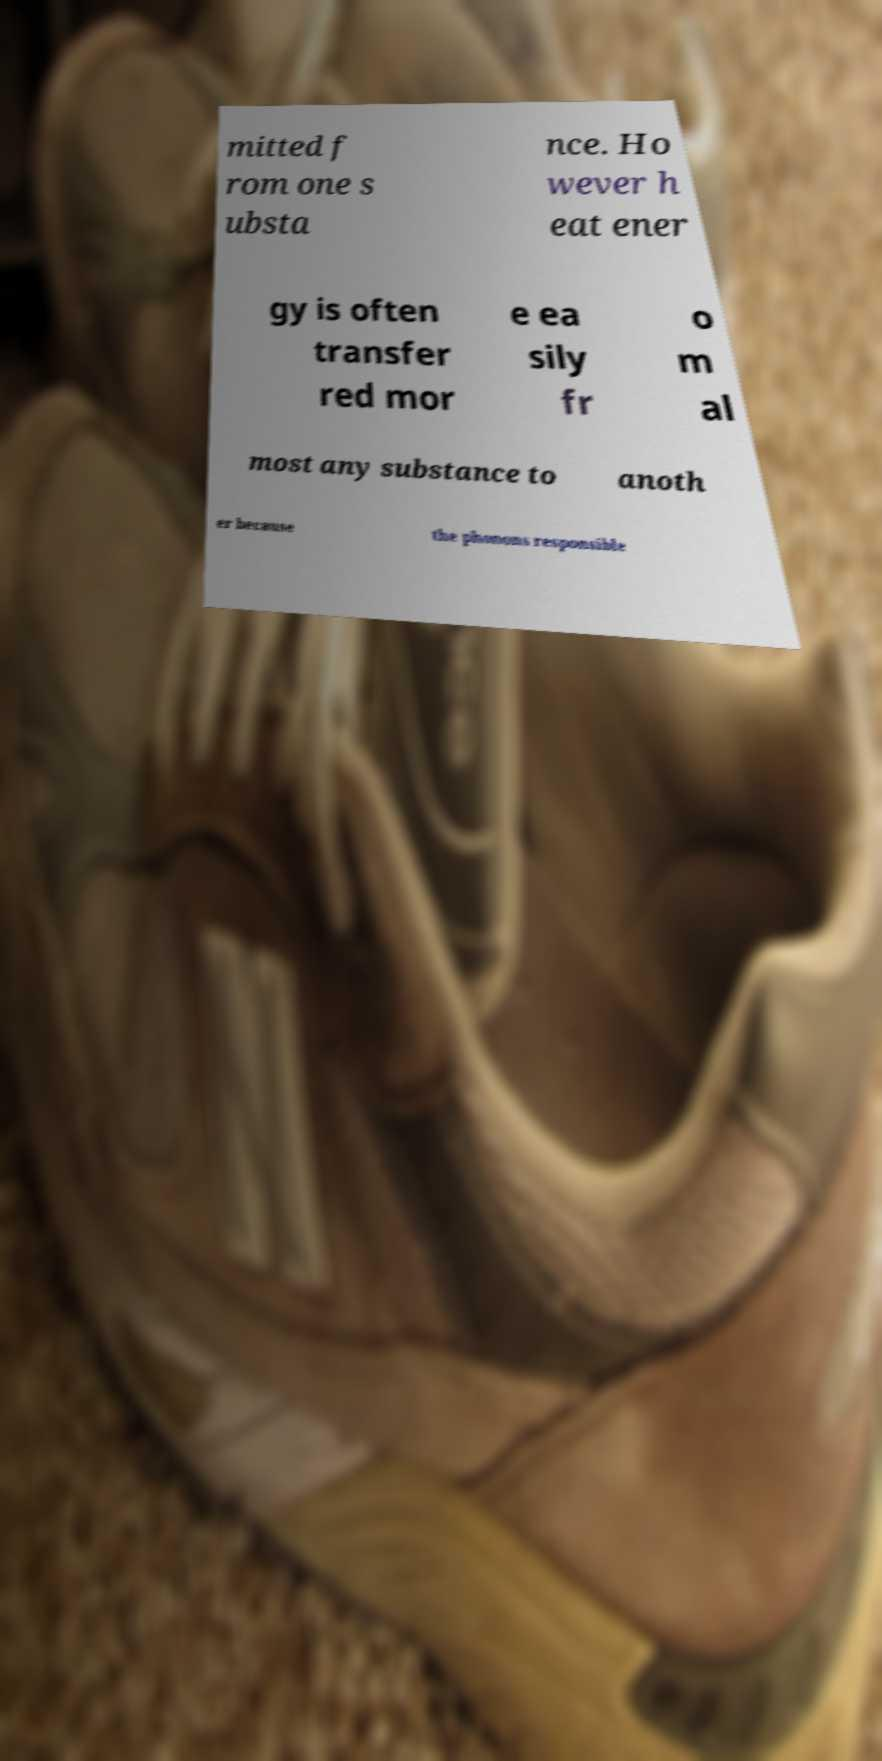Can you read and provide the text displayed in the image?This photo seems to have some interesting text. Can you extract and type it out for me? mitted f rom one s ubsta nce. Ho wever h eat ener gy is often transfer red mor e ea sily fr o m al most any substance to anoth er because the phonons responsible 